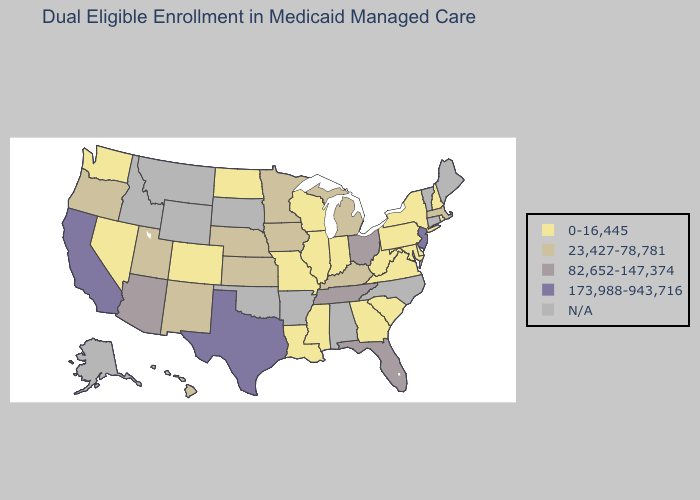What is the value of Kansas?
Quick response, please. 23,427-78,781. Which states have the highest value in the USA?
Write a very short answer. California, New Jersey, Texas. What is the highest value in the Northeast ?
Keep it brief. 173,988-943,716. Does Minnesota have the lowest value in the USA?
Be succinct. No. Which states hav the highest value in the MidWest?
Be succinct. Ohio. Which states have the lowest value in the USA?
Give a very brief answer. Colorado, Delaware, Georgia, Illinois, Indiana, Louisiana, Maryland, Mississippi, Missouri, Nevada, New Hampshire, New York, North Dakota, Pennsylvania, Rhode Island, South Carolina, Virginia, Washington, West Virginia, Wisconsin. What is the value of Maryland?
Quick response, please. 0-16,445. What is the highest value in states that border Wyoming?
Answer briefly. 23,427-78,781. Among the states that border Tennessee , which have the lowest value?
Write a very short answer. Georgia, Mississippi, Missouri, Virginia. Name the states that have a value in the range 0-16,445?
Give a very brief answer. Colorado, Delaware, Georgia, Illinois, Indiana, Louisiana, Maryland, Mississippi, Missouri, Nevada, New Hampshire, New York, North Dakota, Pennsylvania, Rhode Island, South Carolina, Virginia, Washington, West Virginia, Wisconsin. Does the map have missing data?
Give a very brief answer. Yes. Among the states that border Missouri , does Nebraska have the lowest value?
Keep it brief. No. 